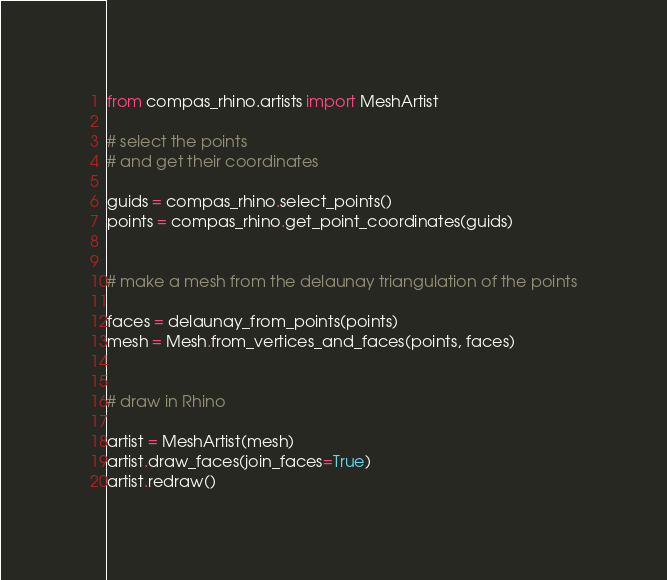Convert code to text. <code><loc_0><loc_0><loc_500><loc_500><_Python_>
from compas_rhino.artists import MeshArtist

# select the points
# and get their coordinates

guids = compas_rhino.select_points()
points = compas_rhino.get_point_coordinates(guids)


# make a mesh from the delaunay triangulation of the points

faces = delaunay_from_points(points)
mesh = Mesh.from_vertices_and_faces(points, faces)


# draw in Rhino

artist = MeshArtist(mesh)
artist.draw_faces(join_faces=True)
artist.redraw()
</code> 